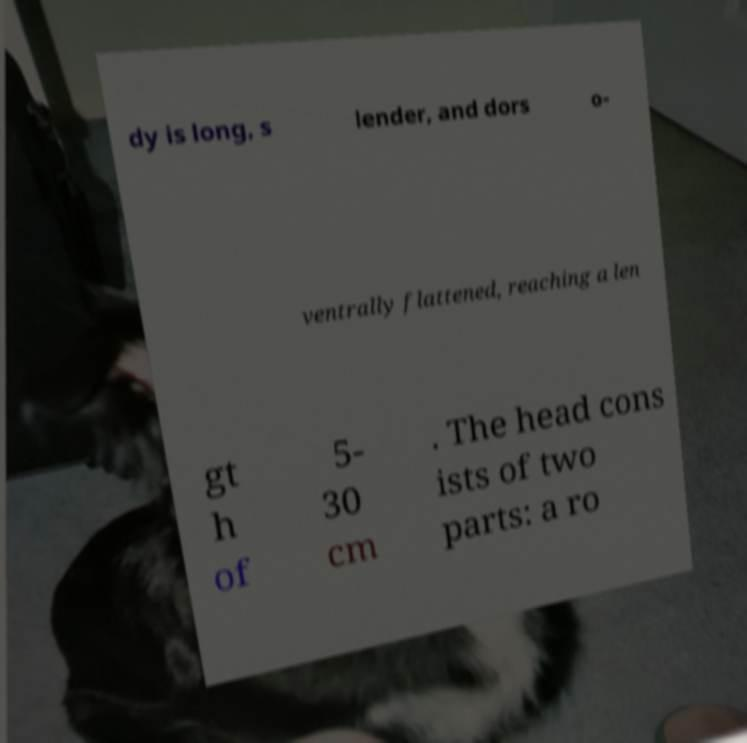What messages or text are displayed in this image? I need them in a readable, typed format. dy is long, s lender, and dors o- ventrally flattened, reaching a len gt h of 5- 30 cm . The head cons ists of two parts: a ro 